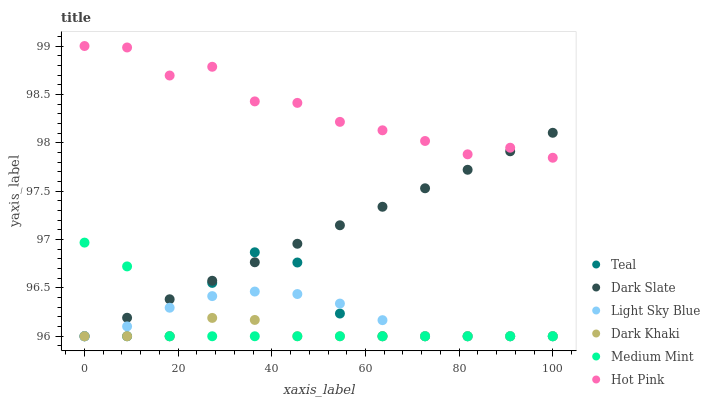Does Dark Khaki have the minimum area under the curve?
Answer yes or no. Yes. Does Hot Pink have the maximum area under the curve?
Answer yes or no. Yes. Does Hot Pink have the minimum area under the curve?
Answer yes or no. No. Does Dark Khaki have the maximum area under the curve?
Answer yes or no. No. Is Dark Slate the smoothest?
Answer yes or no. Yes. Is Hot Pink the roughest?
Answer yes or no. Yes. Is Dark Khaki the smoothest?
Answer yes or no. No. Is Dark Khaki the roughest?
Answer yes or no. No. Does Medium Mint have the lowest value?
Answer yes or no. Yes. Does Hot Pink have the lowest value?
Answer yes or no. No. Does Hot Pink have the highest value?
Answer yes or no. Yes. Does Dark Khaki have the highest value?
Answer yes or no. No. Is Medium Mint less than Hot Pink?
Answer yes or no. Yes. Is Hot Pink greater than Teal?
Answer yes or no. Yes. Does Dark Slate intersect Dark Khaki?
Answer yes or no. Yes. Is Dark Slate less than Dark Khaki?
Answer yes or no. No. Is Dark Slate greater than Dark Khaki?
Answer yes or no. No. Does Medium Mint intersect Hot Pink?
Answer yes or no. No. 